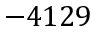<formula> <loc_0><loc_0><loc_500><loc_500>- 4 1 2 9</formula> 